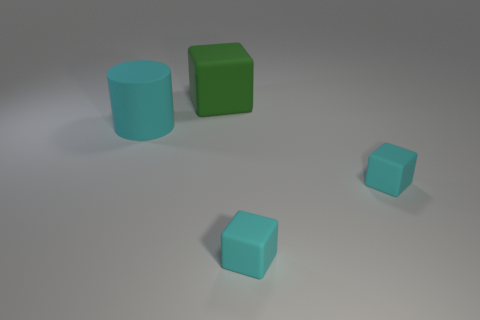Subtract all small cyan matte cubes. How many cubes are left? 1 Subtract all cubes. How many objects are left? 1 Subtract all green cubes. How many cubes are left? 2 Subtract all blue cylinders. How many cyan cubes are left? 2 Subtract all large green rubber blocks. Subtract all large cyan things. How many objects are left? 2 Add 3 big green things. How many big green things are left? 4 Add 2 large cyan rubber objects. How many large cyan rubber objects exist? 3 Add 1 big cyan objects. How many objects exist? 5 Subtract 0 yellow balls. How many objects are left? 4 Subtract all yellow cubes. Subtract all yellow cylinders. How many cubes are left? 3 